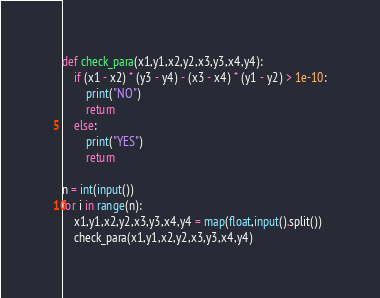Convert code to text. <code><loc_0><loc_0><loc_500><loc_500><_Python_>def check_para(x1,y1,x2,y2,x3,y3,x4,y4):
    if (x1 - x2) * (y3 - y4) - (x3 - x4) * (y1 - y2) > 1e-10:
        print("NO")
        return
    else:
        print("YES")
        return

n = int(input())
for i in range(n):
    x1,y1,x2,y2,x3,y3,x4,y4 = map(float,input().split())
    check_para(x1,y1,x2,y2,x3,y3,x4,y4)</code> 